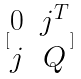Convert formula to latex. <formula><loc_0><loc_0><loc_500><loc_500>[ \begin{matrix} 0 & j ^ { T } \\ j & Q \end{matrix} ]</formula> 